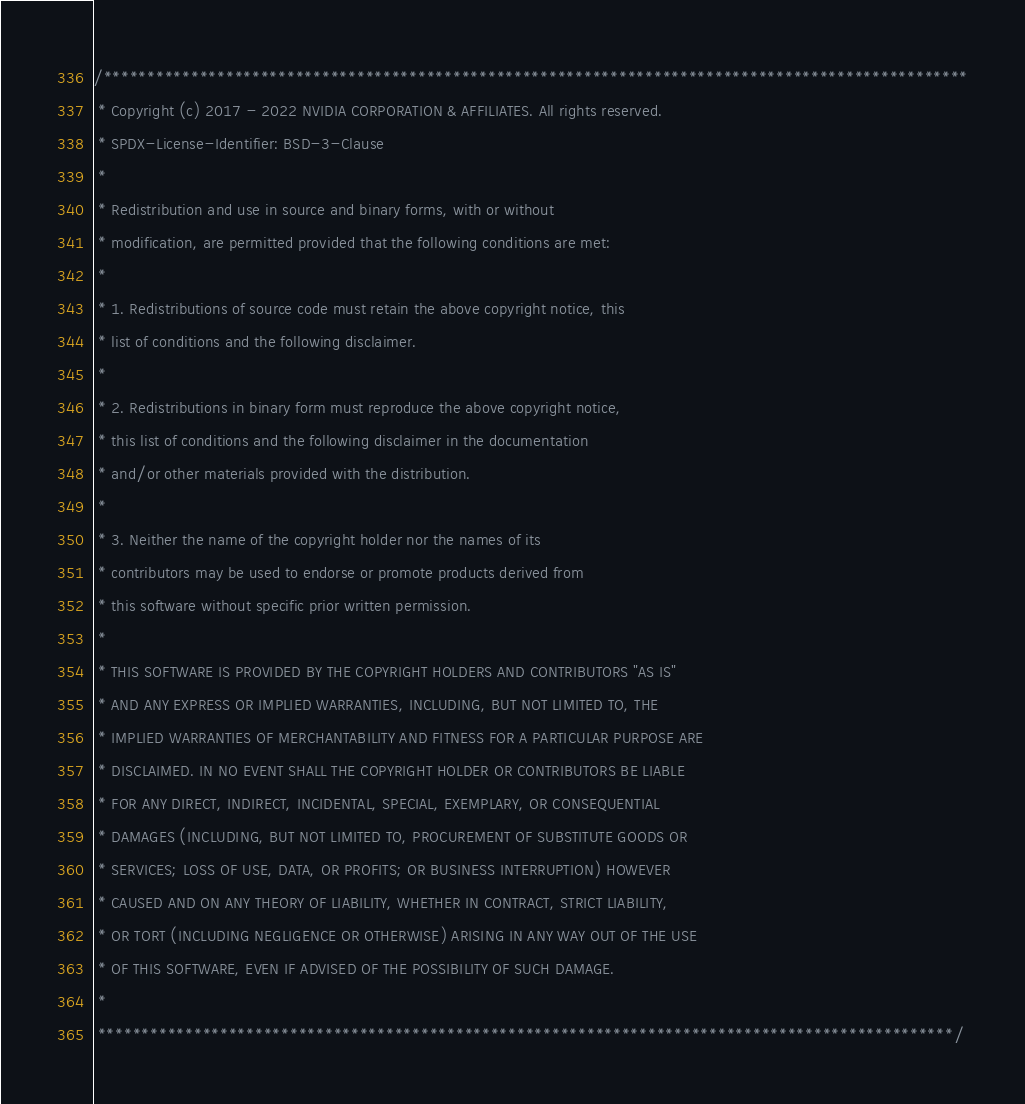Convert code to text. <code><loc_0><loc_0><loc_500><loc_500><_Cuda_>/***************************************************************************************************
 * Copyright (c) 2017 - 2022 NVIDIA CORPORATION & AFFILIATES. All rights reserved.
 * SPDX-License-Identifier: BSD-3-Clause
 *
 * Redistribution and use in source and binary forms, with or without
 * modification, are permitted provided that the following conditions are met:
 *
 * 1. Redistributions of source code must retain the above copyright notice, this
 * list of conditions and the following disclaimer.
 *
 * 2. Redistributions in binary form must reproduce the above copyright notice,
 * this list of conditions and the following disclaimer in the documentation
 * and/or other materials provided with the distribution.
 *
 * 3. Neither the name of the copyright holder nor the names of its
 * contributors may be used to endorse or promote products derived from
 * this software without specific prior written permission.
 *
 * THIS SOFTWARE IS PROVIDED BY THE COPYRIGHT HOLDERS AND CONTRIBUTORS "AS IS"
 * AND ANY EXPRESS OR IMPLIED WARRANTIES, INCLUDING, BUT NOT LIMITED TO, THE
 * IMPLIED WARRANTIES OF MERCHANTABILITY AND FITNESS FOR A PARTICULAR PURPOSE ARE
 * DISCLAIMED. IN NO EVENT SHALL THE COPYRIGHT HOLDER OR CONTRIBUTORS BE LIABLE
 * FOR ANY DIRECT, INDIRECT, INCIDENTAL, SPECIAL, EXEMPLARY, OR CONSEQUENTIAL
 * DAMAGES (INCLUDING, BUT NOT LIMITED TO, PROCUREMENT OF SUBSTITUTE GOODS OR
 * SERVICES; LOSS OF USE, DATA, OR PROFITS; OR BUSINESS INTERRUPTION) HOWEVER
 * CAUSED AND ON ANY THEORY OF LIABILITY, WHETHER IN CONTRACT, STRICT LIABILITY,
 * OR TORT (INCLUDING NEGLIGENCE OR OTHERWISE) ARISING IN ANY WAY OUT OF THE USE
 * OF THIS SOFTWARE, EVEN IF ADVISED OF THE POSSIBILITY OF SUCH DAMAGE.
 *
 **************************************************************************************************/</code> 